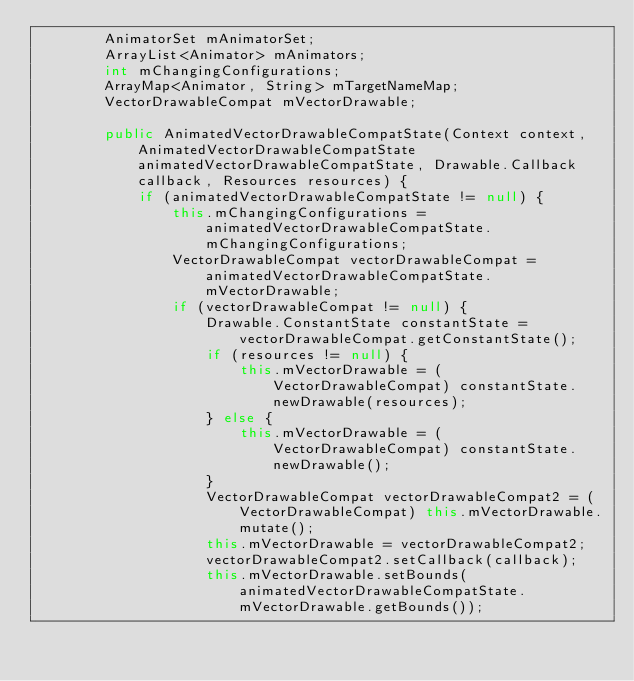<code> <loc_0><loc_0><loc_500><loc_500><_Java_>        AnimatorSet mAnimatorSet;
        ArrayList<Animator> mAnimators;
        int mChangingConfigurations;
        ArrayMap<Animator, String> mTargetNameMap;
        VectorDrawableCompat mVectorDrawable;

        public AnimatedVectorDrawableCompatState(Context context, AnimatedVectorDrawableCompatState animatedVectorDrawableCompatState, Drawable.Callback callback, Resources resources) {
            if (animatedVectorDrawableCompatState != null) {
                this.mChangingConfigurations = animatedVectorDrawableCompatState.mChangingConfigurations;
                VectorDrawableCompat vectorDrawableCompat = animatedVectorDrawableCompatState.mVectorDrawable;
                if (vectorDrawableCompat != null) {
                    Drawable.ConstantState constantState = vectorDrawableCompat.getConstantState();
                    if (resources != null) {
                        this.mVectorDrawable = (VectorDrawableCompat) constantState.newDrawable(resources);
                    } else {
                        this.mVectorDrawable = (VectorDrawableCompat) constantState.newDrawable();
                    }
                    VectorDrawableCompat vectorDrawableCompat2 = (VectorDrawableCompat) this.mVectorDrawable.mutate();
                    this.mVectorDrawable = vectorDrawableCompat2;
                    vectorDrawableCompat2.setCallback(callback);
                    this.mVectorDrawable.setBounds(animatedVectorDrawableCompatState.mVectorDrawable.getBounds());</code> 